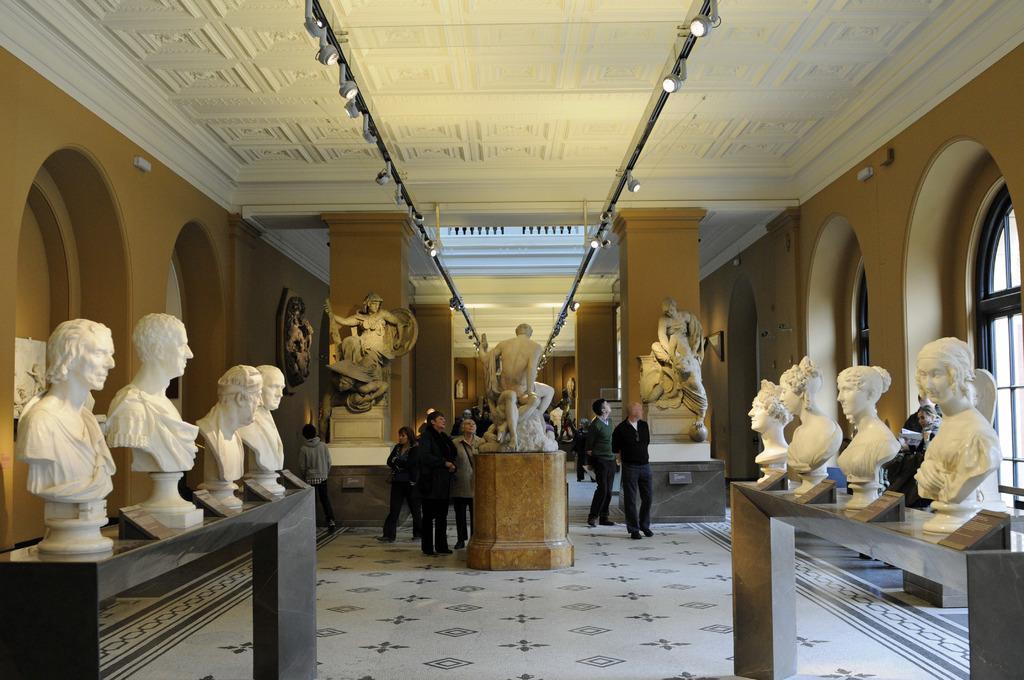Could you give a brief overview of what you see in this image? In this picture we can see statues, name boards, windows, lights, pillars, roof and a group of people standing on the floor. 